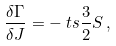<formula> <loc_0><loc_0><loc_500><loc_500>\frac { \delta \Gamma } { \delta J } & = - { \ t s \frac { 3 } { 2 } } S \, ,</formula> 